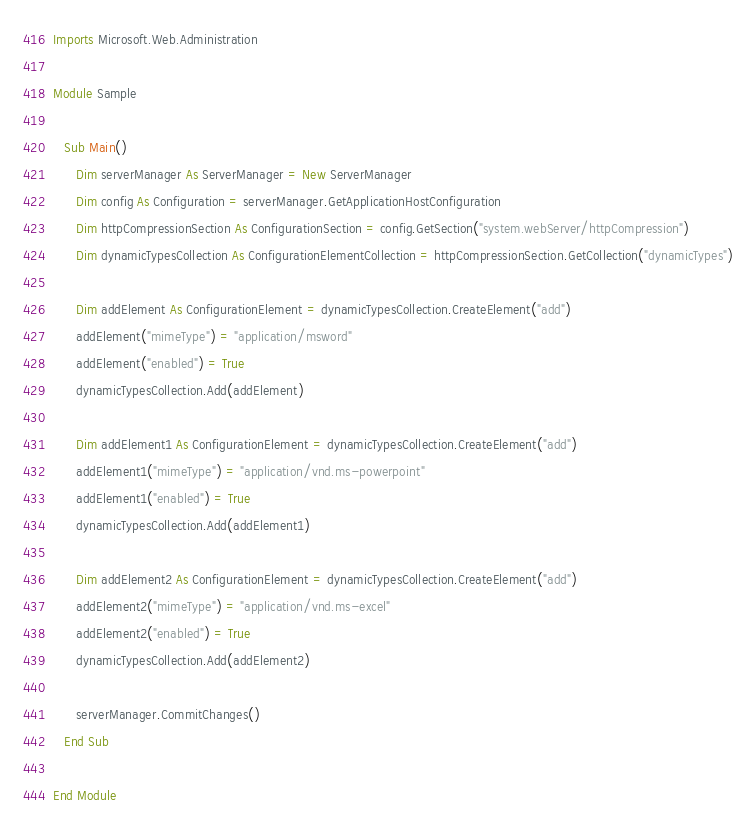<code> <loc_0><loc_0><loc_500><loc_500><_VisualBasic_>Imports Microsoft.Web.Administration

Module Sample

   Sub Main()
      Dim serverManager As ServerManager = New ServerManager
      Dim config As Configuration = serverManager.GetApplicationHostConfiguration
      Dim httpCompressionSection As ConfigurationSection = config.GetSection("system.webServer/httpCompression")
      Dim dynamicTypesCollection As ConfigurationElementCollection = httpCompressionSection.GetCollection("dynamicTypes")

      Dim addElement As ConfigurationElement = dynamicTypesCollection.CreateElement("add")
      addElement("mimeType") = "application/msword"
      addElement("enabled") = True
      dynamicTypesCollection.Add(addElement)

      Dim addElement1 As ConfigurationElement = dynamicTypesCollection.CreateElement("add")
      addElement1("mimeType") = "application/vnd.ms-powerpoint"
      addElement1("enabled") = True
      dynamicTypesCollection.Add(addElement1)

      Dim addElement2 As ConfigurationElement = dynamicTypesCollection.CreateElement("add")
      addElement2("mimeType") = "application/vnd.ms-excel"
      addElement2("enabled") = True
      dynamicTypesCollection.Add(addElement2)

      serverManager.CommitChanges()
   End Sub

End Module</code> 